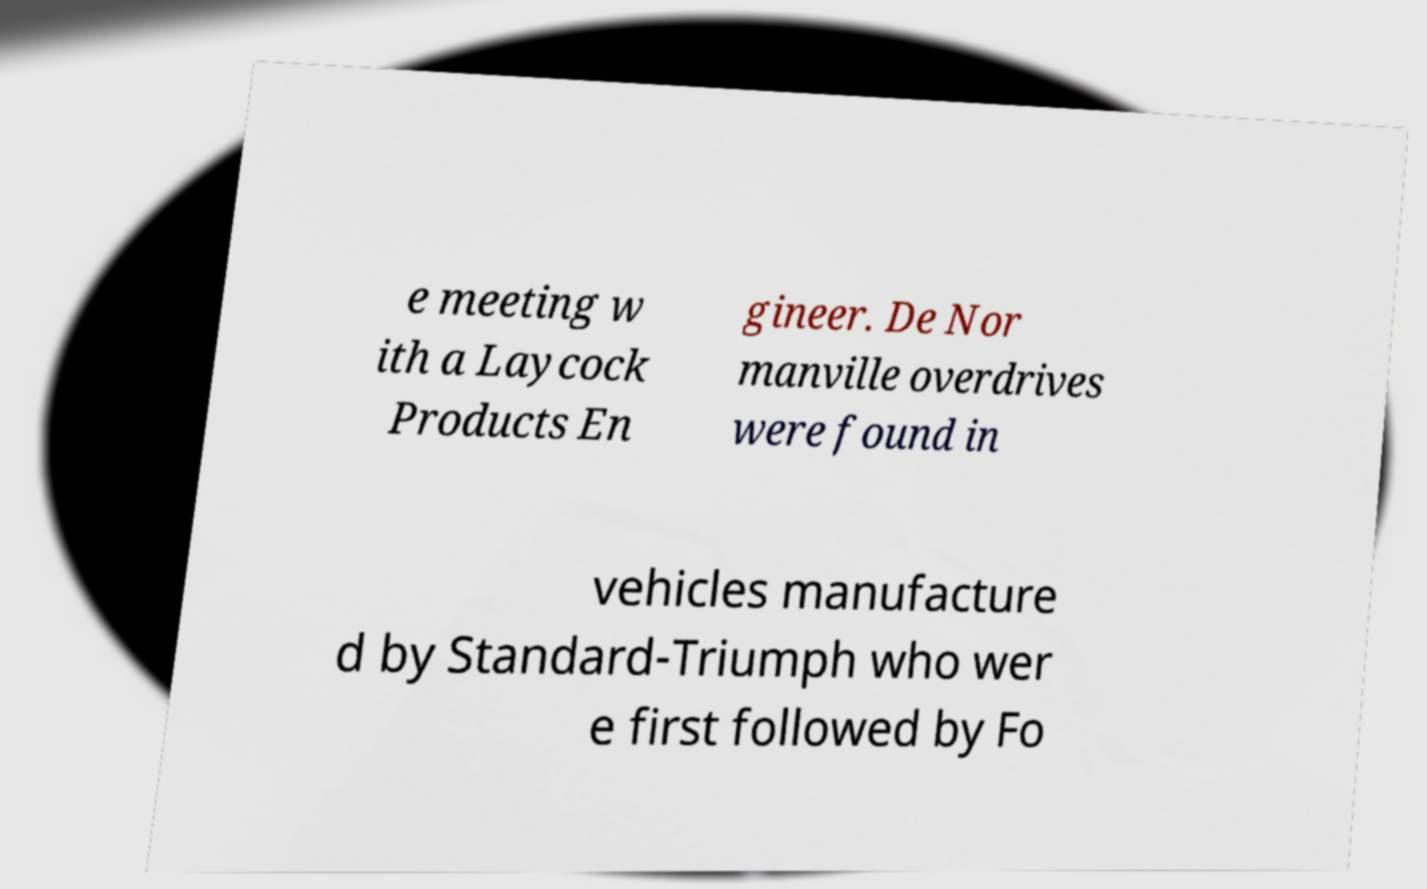Can you read and provide the text displayed in the image?This photo seems to have some interesting text. Can you extract and type it out for me? e meeting w ith a Laycock Products En gineer. De Nor manville overdrives were found in vehicles manufacture d by Standard-Triumph who wer e first followed by Fo 